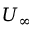Convert formula to latex. <formula><loc_0><loc_0><loc_500><loc_500>U _ { \infty }</formula> 